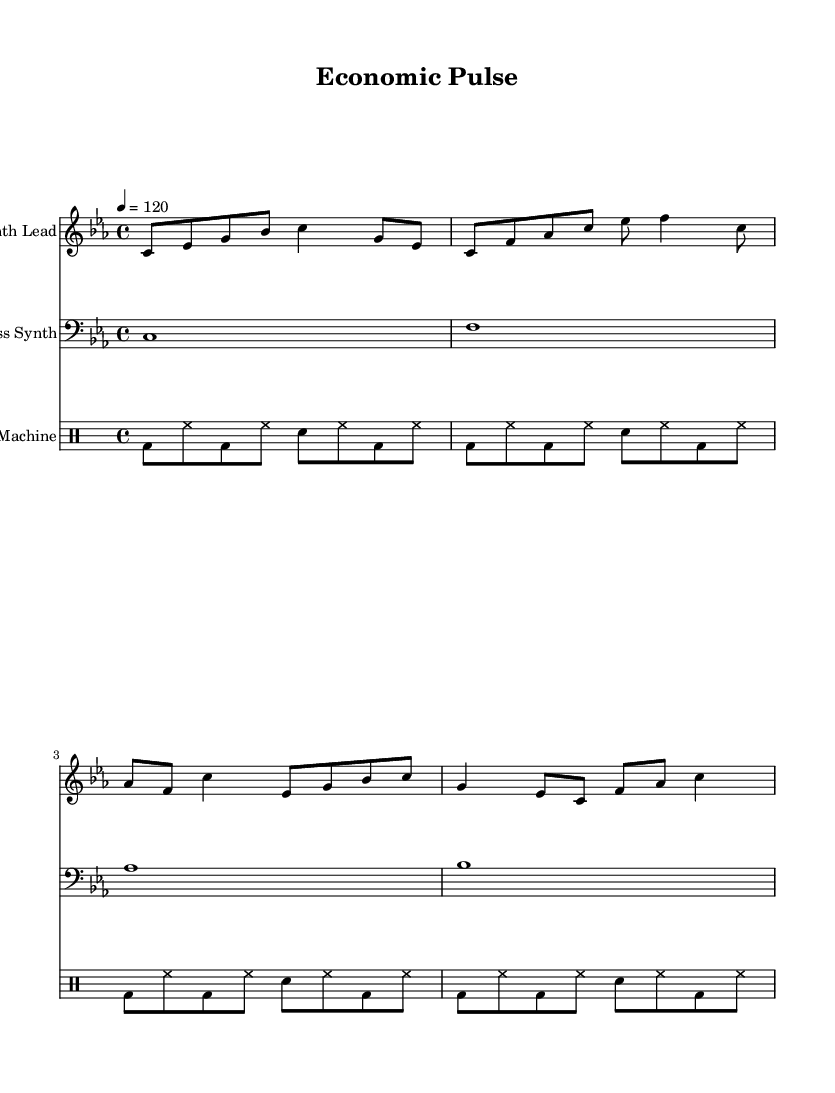what is the key signature of this music? The key signature is C minor, which has three flats (B-flat, E-flat, and A-flat) indicated in the notation at the beginning of the staff.
Answer: C minor what is the time signature of this music? The time signature is 4/4, denoted at the start of the score, indicating that there are four beats per measure and the quarter note receives one beat.
Answer: 4/4 what is the tempo marking of this piece? The tempo is marked as 120 beats per minute, indicated by the tempo marking near the beginning of the score.
Answer: 120 how many measures are in the synth lead part? There are four measures in the synth lead part, as can be observed by counting the sequential groupings of the symbols across the staff.
Answer: 4 what is the note played in the first measure of the bass synth? The bass synth plays a C note in the first measure, as indicated by the notehead placed on the C line of the bass clef.
Answer: C how does the drum pattern vary between the measures? The drum pattern remains consistent across all measures, utilizing a repeated pattern of bass drums, hi-hats, and snare drums, creating a steady electronic beat throughout.
Answer: Consistent what type of instrument is indicated for the synth lead? The synth lead is performed on a synthesizer, as indicated by the instrument name at the top of the staff.
Answer: Synthesizer 